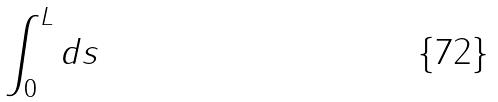Convert formula to latex. <formula><loc_0><loc_0><loc_500><loc_500>\int _ { 0 } ^ { L } d s</formula> 